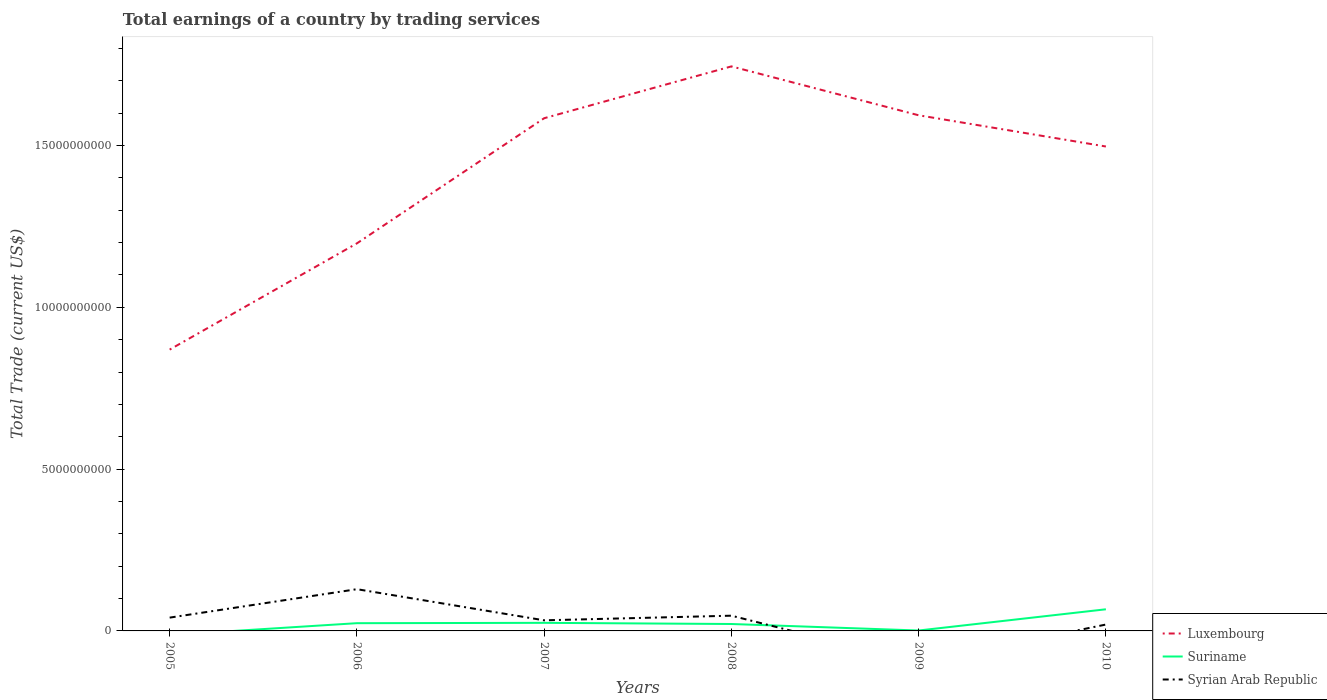Does the line corresponding to Syrian Arab Republic intersect with the line corresponding to Suriname?
Offer a terse response. Yes. Is the number of lines equal to the number of legend labels?
Provide a succinct answer. No. Across all years, what is the maximum total earnings in Luxembourg?
Offer a terse response. 8.69e+09. What is the total total earnings in Suriname in the graph?
Provide a succinct answer. 2.37e+08. What is the difference between the highest and the second highest total earnings in Luxembourg?
Make the answer very short. 8.75e+09. How many lines are there?
Make the answer very short. 3. What is the difference between two consecutive major ticks on the Y-axis?
Give a very brief answer. 5.00e+09. Does the graph contain any zero values?
Offer a very short reply. Yes. How many legend labels are there?
Offer a very short reply. 3. What is the title of the graph?
Keep it short and to the point. Total earnings of a country by trading services. What is the label or title of the Y-axis?
Give a very brief answer. Total Trade (current US$). What is the Total Trade (current US$) in Luxembourg in 2005?
Make the answer very short. 8.69e+09. What is the Total Trade (current US$) of Syrian Arab Republic in 2005?
Ensure brevity in your answer.  4.11e+08. What is the Total Trade (current US$) of Luxembourg in 2006?
Provide a short and direct response. 1.20e+1. What is the Total Trade (current US$) in Suriname in 2006?
Your answer should be very brief. 2.39e+08. What is the Total Trade (current US$) in Syrian Arab Republic in 2006?
Your response must be concise. 1.29e+09. What is the Total Trade (current US$) in Luxembourg in 2007?
Offer a very short reply. 1.58e+1. What is the Total Trade (current US$) of Suriname in 2007?
Your answer should be very brief. 2.50e+08. What is the Total Trade (current US$) of Syrian Arab Republic in 2007?
Give a very brief answer. 3.28e+08. What is the Total Trade (current US$) of Luxembourg in 2008?
Keep it short and to the point. 1.74e+1. What is the Total Trade (current US$) of Suriname in 2008?
Ensure brevity in your answer.  2.14e+08. What is the Total Trade (current US$) of Syrian Arab Republic in 2008?
Offer a terse response. 4.71e+08. What is the Total Trade (current US$) of Luxembourg in 2009?
Offer a terse response. 1.59e+1. What is the Total Trade (current US$) of Suriname in 2009?
Your answer should be compact. 1.25e+07. What is the Total Trade (current US$) in Syrian Arab Republic in 2009?
Your answer should be very brief. 0. What is the Total Trade (current US$) in Luxembourg in 2010?
Your answer should be very brief. 1.50e+1. What is the Total Trade (current US$) in Suriname in 2010?
Your answer should be very brief. 6.69e+08. What is the Total Trade (current US$) of Syrian Arab Republic in 2010?
Offer a very short reply. 1.97e+08. Across all years, what is the maximum Total Trade (current US$) of Luxembourg?
Make the answer very short. 1.74e+1. Across all years, what is the maximum Total Trade (current US$) in Suriname?
Your answer should be compact. 6.69e+08. Across all years, what is the maximum Total Trade (current US$) in Syrian Arab Republic?
Keep it short and to the point. 1.29e+09. Across all years, what is the minimum Total Trade (current US$) in Luxembourg?
Provide a succinct answer. 8.69e+09. Across all years, what is the minimum Total Trade (current US$) in Suriname?
Offer a terse response. 0. What is the total Total Trade (current US$) of Luxembourg in the graph?
Make the answer very short. 8.49e+1. What is the total Total Trade (current US$) of Suriname in the graph?
Your response must be concise. 1.38e+09. What is the total Total Trade (current US$) of Syrian Arab Republic in the graph?
Your answer should be very brief. 2.70e+09. What is the difference between the Total Trade (current US$) of Luxembourg in 2005 and that in 2006?
Provide a succinct answer. -3.28e+09. What is the difference between the Total Trade (current US$) in Syrian Arab Republic in 2005 and that in 2006?
Your answer should be very brief. -8.79e+08. What is the difference between the Total Trade (current US$) in Luxembourg in 2005 and that in 2007?
Keep it short and to the point. -7.15e+09. What is the difference between the Total Trade (current US$) of Syrian Arab Republic in 2005 and that in 2007?
Offer a very short reply. 8.33e+07. What is the difference between the Total Trade (current US$) of Luxembourg in 2005 and that in 2008?
Ensure brevity in your answer.  -8.75e+09. What is the difference between the Total Trade (current US$) of Syrian Arab Republic in 2005 and that in 2008?
Your answer should be very brief. -5.99e+07. What is the difference between the Total Trade (current US$) of Luxembourg in 2005 and that in 2009?
Provide a succinct answer. -7.24e+09. What is the difference between the Total Trade (current US$) in Luxembourg in 2005 and that in 2010?
Provide a short and direct response. -6.28e+09. What is the difference between the Total Trade (current US$) in Syrian Arab Republic in 2005 and that in 2010?
Offer a terse response. 2.14e+08. What is the difference between the Total Trade (current US$) of Luxembourg in 2006 and that in 2007?
Keep it short and to the point. -3.87e+09. What is the difference between the Total Trade (current US$) of Suriname in 2006 and that in 2007?
Ensure brevity in your answer.  -1.05e+07. What is the difference between the Total Trade (current US$) in Syrian Arab Republic in 2006 and that in 2007?
Keep it short and to the point. 9.62e+08. What is the difference between the Total Trade (current US$) of Luxembourg in 2006 and that in 2008?
Offer a very short reply. -5.47e+09. What is the difference between the Total Trade (current US$) in Suriname in 2006 and that in 2008?
Provide a short and direct response. 2.54e+07. What is the difference between the Total Trade (current US$) in Syrian Arab Republic in 2006 and that in 2008?
Ensure brevity in your answer.  8.19e+08. What is the difference between the Total Trade (current US$) of Luxembourg in 2006 and that in 2009?
Your response must be concise. -3.96e+09. What is the difference between the Total Trade (current US$) in Suriname in 2006 and that in 2009?
Your answer should be very brief. 2.27e+08. What is the difference between the Total Trade (current US$) in Luxembourg in 2006 and that in 2010?
Offer a terse response. -2.99e+09. What is the difference between the Total Trade (current US$) in Suriname in 2006 and that in 2010?
Offer a terse response. -4.29e+08. What is the difference between the Total Trade (current US$) in Syrian Arab Republic in 2006 and that in 2010?
Give a very brief answer. 1.09e+09. What is the difference between the Total Trade (current US$) of Luxembourg in 2007 and that in 2008?
Ensure brevity in your answer.  -1.60e+09. What is the difference between the Total Trade (current US$) in Suriname in 2007 and that in 2008?
Provide a short and direct response. 3.59e+07. What is the difference between the Total Trade (current US$) of Syrian Arab Republic in 2007 and that in 2008?
Your answer should be very brief. -1.43e+08. What is the difference between the Total Trade (current US$) in Luxembourg in 2007 and that in 2009?
Provide a short and direct response. -9.08e+07. What is the difference between the Total Trade (current US$) in Suriname in 2007 and that in 2009?
Give a very brief answer. 2.37e+08. What is the difference between the Total Trade (current US$) in Luxembourg in 2007 and that in 2010?
Give a very brief answer. 8.74e+08. What is the difference between the Total Trade (current US$) of Suriname in 2007 and that in 2010?
Offer a very short reply. -4.19e+08. What is the difference between the Total Trade (current US$) in Syrian Arab Republic in 2007 and that in 2010?
Keep it short and to the point. 1.31e+08. What is the difference between the Total Trade (current US$) in Luxembourg in 2008 and that in 2009?
Offer a very short reply. 1.51e+09. What is the difference between the Total Trade (current US$) of Suriname in 2008 and that in 2009?
Provide a short and direct response. 2.01e+08. What is the difference between the Total Trade (current US$) in Luxembourg in 2008 and that in 2010?
Provide a succinct answer. 2.48e+09. What is the difference between the Total Trade (current US$) of Suriname in 2008 and that in 2010?
Ensure brevity in your answer.  -4.55e+08. What is the difference between the Total Trade (current US$) in Syrian Arab Republic in 2008 and that in 2010?
Ensure brevity in your answer.  2.74e+08. What is the difference between the Total Trade (current US$) of Luxembourg in 2009 and that in 2010?
Provide a short and direct response. 9.65e+08. What is the difference between the Total Trade (current US$) of Suriname in 2009 and that in 2010?
Give a very brief answer. -6.56e+08. What is the difference between the Total Trade (current US$) in Luxembourg in 2005 and the Total Trade (current US$) in Suriname in 2006?
Ensure brevity in your answer.  8.45e+09. What is the difference between the Total Trade (current US$) in Luxembourg in 2005 and the Total Trade (current US$) in Syrian Arab Republic in 2006?
Keep it short and to the point. 7.40e+09. What is the difference between the Total Trade (current US$) of Luxembourg in 2005 and the Total Trade (current US$) of Suriname in 2007?
Ensure brevity in your answer.  8.44e+09. What is the difference between the Total Trade (current US$) in Luxembourg in 2005 and the Total Trade (current US$) in Syrian Arab Republic in 2007?
Make the answer very short. 8.37e+09. What is the difference between the Total Trade (current US$) in Luxembourg in 2005 and the Total Trade (current US$) in Suriname in 2008?
Your answer should be compact. 8.48e+09. What is the difference between the Total Trade (current US$) in Luxembourg in 2005 and the Total Trade (current US$) in Syrian Arab Republic in 2008?
Provide a short and direct response. 8.22e+09. What is the difference between the Total Trade (current US$) in Luxembourg in 2005 and the Total Trade (current US$) in Suriname in 2009?
Your response must be concise. 8.68e+09. What is the difference between the Total Trade (current US$) of Luxembourg in 2005 and the Total Trade (current US$) of Suriname in 2010?
Make the answer very short. 8.03e+09. What is the difference between the Total Trade (current US$) in Luxembourg in 2005 and the Total Trade (current US$) in Syrian Arab Republic in 2010?
Provide a short and direct response. 8.50e+09. What is the difference between the Total Trade (current US$) in Luxembourg in 2006 and the Total Trade (current US$) in Suriname in 2007?
Your response must be concise. 1.17e+1. What is the difference between the Total Trade (current US$) of Luxembourg in 2006 and the Total Trade (current US$) of Syrian Arab Republic in 2007?
Offer a terse response. 1.16e+1. What is the difference between the Total Trade (current US$) in Suriname in 2006 and the Total Trade (current US$) in Syrian Arab Republic in 2007?
Your answer should be very brief. -8.85e+07. What is the difference between the Total Trade (current US$) of Luxembourg in 2006 and the Total Trade (current US$) of Suriname in 2008?
Provide a short and direct response. 1.18e+1. What is the difference between the Total Trade (current US$) in Luxembourg in 2006 and the Total Trade (current US$) in Syrian Arab Republic in 2008?
Your response must be concise. 1.15e+1. What is the difference between the Total Trade (current US$) of Suriname in 2006 and the Total Trade (current US$) of Syrian Arab Republic in 2008?
Ensure brevity in your answer.  -2.32e+08. What is the difference between the Total Trade (current US$) of Luxembourg in 2006 and the Total Trade (current US$) of Suriname in 2009?
Your response must be concise. 1.20e+1. What is the difference between the Total Trade (current US$) of Luxembourg in 2006 and the Total Trade (current US$) of Suriname in 2010?
Offer a terse response. 1.13e+1. What is the difference between the Total Trade (current US$) in Luxembourg in 2006 and the Total Trade (current US$) in Syrian Arab Republic in 2010?
Offer a terse response. 1.18e+1. What is the difference between the Total Trade (current US$) of Suriname in 2006 and the Total Trade (current US$) of Syrian Arab Republic in 2010?
Provide a succinct answer. 4.22e+07. What is the difference between the Total Trade (current US$) of Luxembourg in 2007 and the Total Trade (current US$) of Suriname in 2008?
Make the answer very short. 1.56e+1. What is the difference between the Total Trade (current US$) of Luxembourg in 2007 and the Total Trade (current US$) of Syrian Arab Republic in 2008?
Give a very brief answer. 1.54e+1. What is the difference between the Total Trade (current US$) in Suriname in 2007 and the Total Trade (current US$) in Syrian Arab Republic in 2008?
Offer a terse response. -2.21e+08. What is the difference between the Total Trade (current US$) of Luxembourg in 2007 and the Total Trade (current US$) of Suriname in 2009?
Offer a terse response. 1.58e+1. What is the difference between the Total Trade (current US$) in Luxembourg in 2007 and the Total Trade (current US$) in Suriname in 2010?
Your answer should be very brief. 1.52e+1. What is the difference between the Total Trade (current US$) in Luxembourg in 2007 and the Total Trade (current US$) in Syrian Arab Republic in 2010?
Your answer should be very brief. 1.56e+1. What is the difference between the Total Trade (current US$) in Suriname in 2007 and the Total Trade (current US$) in Syrian Arab Republic in 2010?
Provide a succinct answer. 5.27e+07. What is the difference between the Total Trade (current US$) in Luxembourg in 2008 and the Total Trade (current US$) in Suriname in 2009?
Your answer should be compact. 1.74e+1. What is the difference between the Total Trade (current US$) of Luxembourg in 2008 and the Total Trade (current US$) of Suriname in 2010?
Your response must be concise. 1.68e+1. What is the difference between the Total Trade (current US$) in Luxembourg in 2008 and the Total Trade (current US$) in Syrian Arab Republic in 2010?
Give a very brief answer. 1.72e+1. What is the difference between the Total Trade (current US$) of Suriname in 2008 and the Total Trade (current US$) of Syrian Arab Republic in 2010?
Keep it short and to the point. 1.68e+07. What is the difference between the Total Trade (current US$) of Luxembourg in 2009 and the Total Trade (current US$) of Suriname in 2010?
Offer a terse response. 1.53e+1. What is the difference between the Total Trade (current US$) of Luxembourg in 2009 and the Total Trade (current US$) of Syrian Arab Republic in 2010?
Offer a very short reply. 1.57e+1. What is the difference between the Total Trade (current US$) of Suriname in 2009 and the Total Trade (current US$) of Syrian Arab Republic in 2010?
Ensure brevity in your answer.  -1.84e+08. What is the average Total Trade (current US$) of Luxembourg per year?
Give a very brief answer. 1.41e+1. What is the average Total Trade (current US$) of Suriname per year?
Provide a succinct answer. 2.31e+08. What is the average Total Trade (current US$) in Syrian Arab Republic per year?
Your answer should be very brief. 4.49e+08. In the year 2005, what is the difference between the Total Trade (current US$) of Luxembourg and Total Trade (current US$) of Syrian Arab Republic?
Give a very brief answer. 8.28e+09. In the year 2006, what is the difference between the Total Trade (current US$) in Luxembourg and Total Trade (current US$) in Suriname?
Your answer should be very brief. 1.17e+1. In the year 2006, what is the difference between the Total Trade (current US$) of Luxembourg and Total Trade (current US$) of Syrian Arab Republic?
Offer a terse response. 1.07e+1. In the year 2006, what is the difference between the Total Trade (current US$) in Suriname and Total Trade (current US$) in Syrian Arab Republic?
Provide a short and direct response. -1.05e+09. In the year 2007, what is the difference between the Total Trade (current US$) of Luxembourg and Total Trade (current US$) of Suriname?
Offer a very short reply. 1.56e+1. In the year 2007, what is the difference between the Total Trade (current US$) in Luxembourg and Total Trade (current US$) in Syrian Arab Republic?
Keep it short and to the point. 1.55e+1. In the year 2007, what is the difference between the Total Trade (current US$) of Suriname and Total Trade (current US$) of Syrian Arab Republic?
Ensure brevity in your answer.  -7.80e+07. In the year 2008, what is the difference between the Total Trade (current US$) in Luxembourg and Total Trade (current US$) in Suriname?
Keep it short and to the point. 1.72e+1. In the year 2008, what is the difference between the Total Trade (current US$) in Luxembourg and Total Trade (current US$) in Syrian Arab Republic?
Your response must be concise. 1.70e+1. In the year 2008, what is the difference between the Total Trade (current US$) in Suriname and Total Trade (current US$) in Syrian Arab Republic?
Offer a very short reply. -2.57e+08. In the year 2009, what is the difference between the Total Trade (current US$) of Luxembourg and Total Trade (current US$) of Suriname?
Give a very brief answer. 1.59e+1. In the year 2010, what is the difference between the Total Trade (current US$) in Luxembourg and Total Trade (current US$) in Suriname?
Offer a very short reply. 1.43e+1. In the year 2010, what is the difference between the Total Trade (current US$) in Luxembourg and Total Trade (current US$) in Syrian Arab Republic?
Give a very brief answer. 1.48e+1. In the year 2010, what is the difference between the Total Trade (current US$) of Suriname and Total Trade (current US$) of Syrian Arab Republic?
Your response must be concise. 4.72e+08. What is the ratio of the Total Trade (current US$) of Luxembourg in 2005 to that in 2006?
Your answer should be very brief. 0.73. What is the ratio of the Total Trade (current US$) of Syrian Arab Republic in 2005 to that in 2006?
Offer a very short reply. 0.32. What is the ratio of the Total Trade (current US$) of Luxembourg in 2005 to that in 2007?
Make the answer very short. 0.55. What is the ratio of the Total Trade (current US$) of Syrian Arab Republic in 2005 to that in 2007?
Provide a short and direct response. 1.25. What is the ratio of the Total Trade (current US$) of Luxembourg in 2005 to that in 2008?
Give a very brief answer. 0.5. What is the ratio of the Total Trade (current US$) of Syrian Arab Republic in 2005 to that in 2008?
Give a very brief answer. 0.87. What is the ratio of the Total Trade (current US$) of Luxembourg in 2005 to that in 2009?
Your answer should be compact. 0.55. What is the ratio of the Total Trade (current US$) of Luxembourg in 2005 to that in 2010?
Ensure brevity in your answer.  0.58. What is the ratio of the Total Trade (current US$) of Syrian Arab Republic in 2005 to that in 2010?
Offer a very short reply. 2.09. What is the ratio of the Total Trade (current US$) in Luxembourg in 2006 to that in 2007?
Make the answer very short. 0.76. What is the ratio of the Total Trade (current US$) of Suriname in 2006 to that in 2007?
Provide a short and direct response. 0.96. What is the ratio of the Total Trade (current US$) of Syrian Arab Republic in 2006 to that in 2007?
Provide a succinct answer. 3.94. What is the ratio of the Total Trade (current US$) in Luxembourg in 2006 to that in 2008?
Ensure brevity in your answer.  0.69. What is the ratio of the Total Trade (current US$) in Suriname in 2006 to that in 2008?
Keep it short and to the point. 1.12. What is the ratio of the Total Trade (current US$) in Syrian Arab Republic in 2006 to that in 2008?
Make the answer very short. 2.74. What is the ratio of the Total Trade (current US$) of Luxembourg in 2006 to that in 2009?
Offer a very short reply. 0.75. What is the ratio of the Total Trade (current US$) in Suriname in 2006 to that in 2009?
Provide a succinct answer. 19.14. What is the ratio of the Total Trade (current US$) of Luxembourg in 2006 to that in 2010?
Offer a very short reply. 0.8. What is the ratio of the Total Trade (current US$) in Suriname in 2006 to that in 2010?
Offer a very short reply. 0.36. What is the ratio of the Total Trade (current US$) of Syrian Arab Republic in 2006 to that in 2010?
Your response must be concise. 6.55. What is the ratio of the Total Trade (current US$) in Luxembourg in 2007 to that in 2008?
Provide a succinct answer. 0.91. What is the ratio of the Total Trade (current US$) of Suriname in 2007 to that in 2008?
Your response must be concise. 1.17. What is the ratio of the Total Trade (current US$) in Syrian Arab Republic in 2007 to that in 2008?
Ensure brevity in your answer.  0.7. What is the ratio of the Total Trade (current US$) of Suriname in 2007 to that in 2009?
Ensure brevity in your answer.  19.98. What is the ratio of the Total Trade (current US$) in Luxembourg in 2007 to that in 2010?
Your answer should be very brief. 1.06. What is the ratio of the Total Trade (current US$) in Suriname in 2007 to that in 2010?
Keep it short and to the point. 0.37. What is the ratio of the Total Trade (current US$) in Syrian Arab Republic in 2007 to that in 2010?
Your answer should be very brief. 1.66. What is the ratio of the Total Trade (current US$) in Luxembourg in 2008 to that in 2009?
Ensure brevity in your answer.  1.09. What is the ratio of the Total Trade (current US$) of Suriname in 2008 to that in 2009?
Offer a terse response. 17.1. What is the ratio of the Total Trade (current US$) of Luxembourg in 2008 to that in 2010?
Ensure brevity in your answer.  1.17. What is the ratio of the Total Trade (current US$) of Suriname in 2008 to that in 2010?
Make the answer very short. 0.32. What is the ratio of the Total Trade (current US$) in Syrian Arab Republic in 2008 to that in 2010?
Your response must be concise. 2.39. What is the ratio of the Total Trade (current US$) in Luxembourg in 2009 to that in 2010?
Offer a very short reply. 1.06. What is the ratio of the Total Trade (current US$) of Suriname in 2009 to that in 2010?
Offer a very short reply. 0.02. What is the difference between the highest and the second highest Total Trade (current US$) in Luxembourg?
Give a very brief answer. 1.51e+09. What is the difference between the highest and the second highest Total Trade (current US$) of Suriname?
Make the answer very short. 4.19e+08. What is the difference between the highest and the second highest Total Trade (current US$) of Syrian Arab Republic?
Provide a succinct answer. 8.19e+08. What is the difference between the highest and the lowest Total Trade (current US$) of Luxembourg?
Ensure brevity in your answer.  8.75e+09. What is the difference between the highest and the lowest Total Trade (current US$) of Suriname?
Offer a terse response. 6.69e+08. What is the difference between the highest and the lowest Total Trade (current US$) of Syrian Arab Republic?
Offer a very short reply. 1.29e+09. 